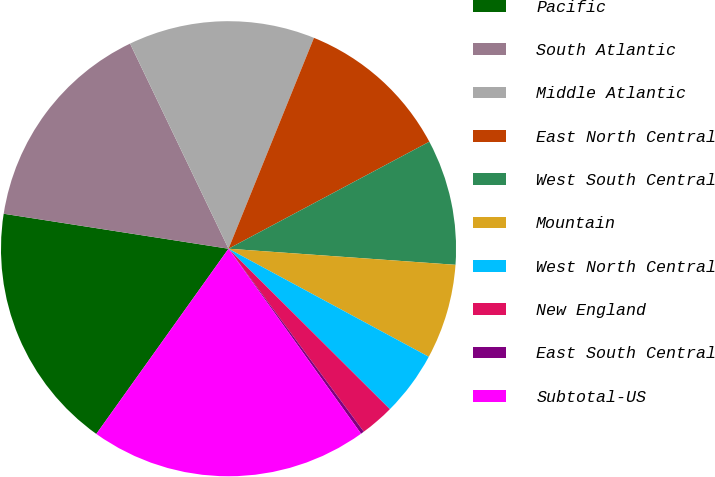Convert chart. <chart><loc_0><loc_0><loc_500><loc_500><pie_chart><fcel>Pacific<fcel>South Atlantic<fcel>Middle Atlantic<fcel>East North Central<fcel>West South Central<fcel>Mountain<fcel>West North Central<fcel>New England<fcel>East South Central<fcel>Subtotal-US<nl><fcel>17.59%<fcel>15.42%<fcel>13.25%<fcel>11.08%<fcel>8.92%<fcel>6.75%<fcel>4.58%<fcel>2.41%<fcel>0.24%<fcel>19.76%<nl></chart> 